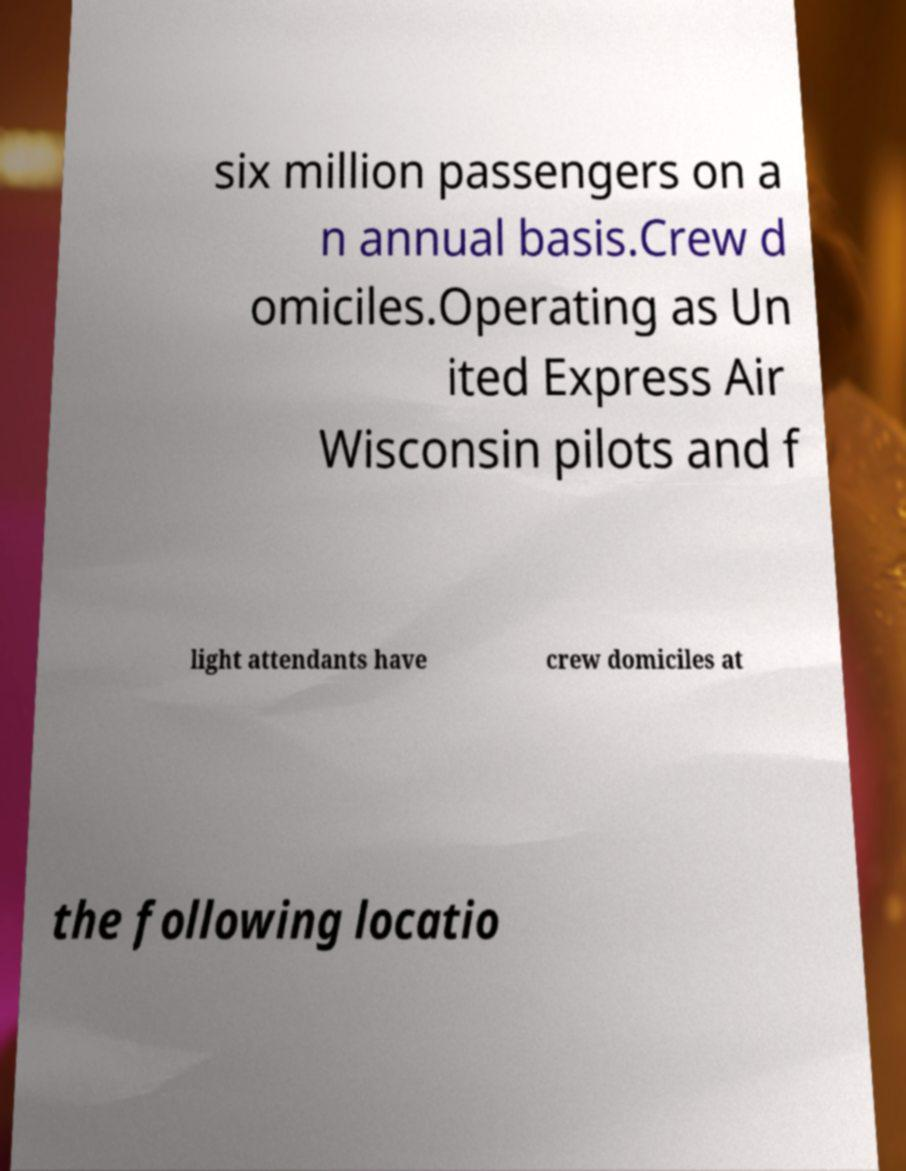Can you accurately transcribe the text from the provided image for me? six million passengers on a n annual basis.Crew d omiciles.Operating as Un ited Express Air Wisconsin pilots and f light attendants have crew domiciles at the following locatio 